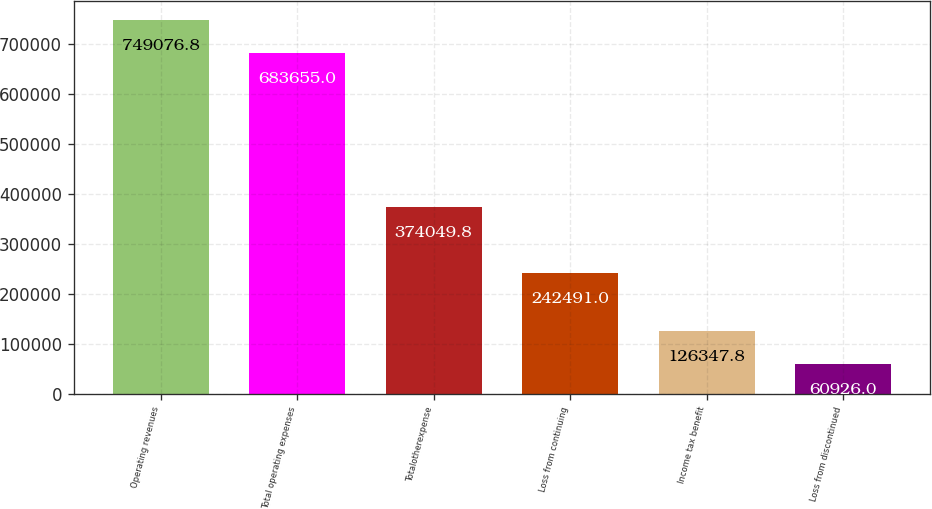Convert chart to OTSL. <chart><loc_0><loc_0><loc_500><loc_500><bar_chart><fcel>Operating revenues<fcel>Total operating expenses<fcel>Totalotherexpense<fcel>Loss from continuing<fcel>Income tax benefit<fcel>Loss from discontinued<nl><fcel>749077<fcel>683655<fcel>374050<fcel>242491<fcel>126348<fcel>60926<nl></chart> 